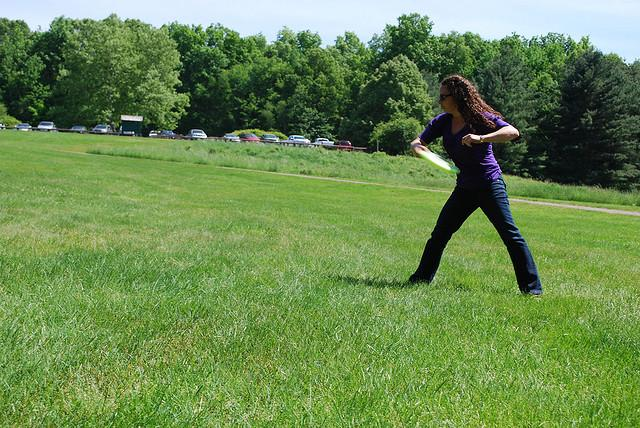What color are her glasses? black 